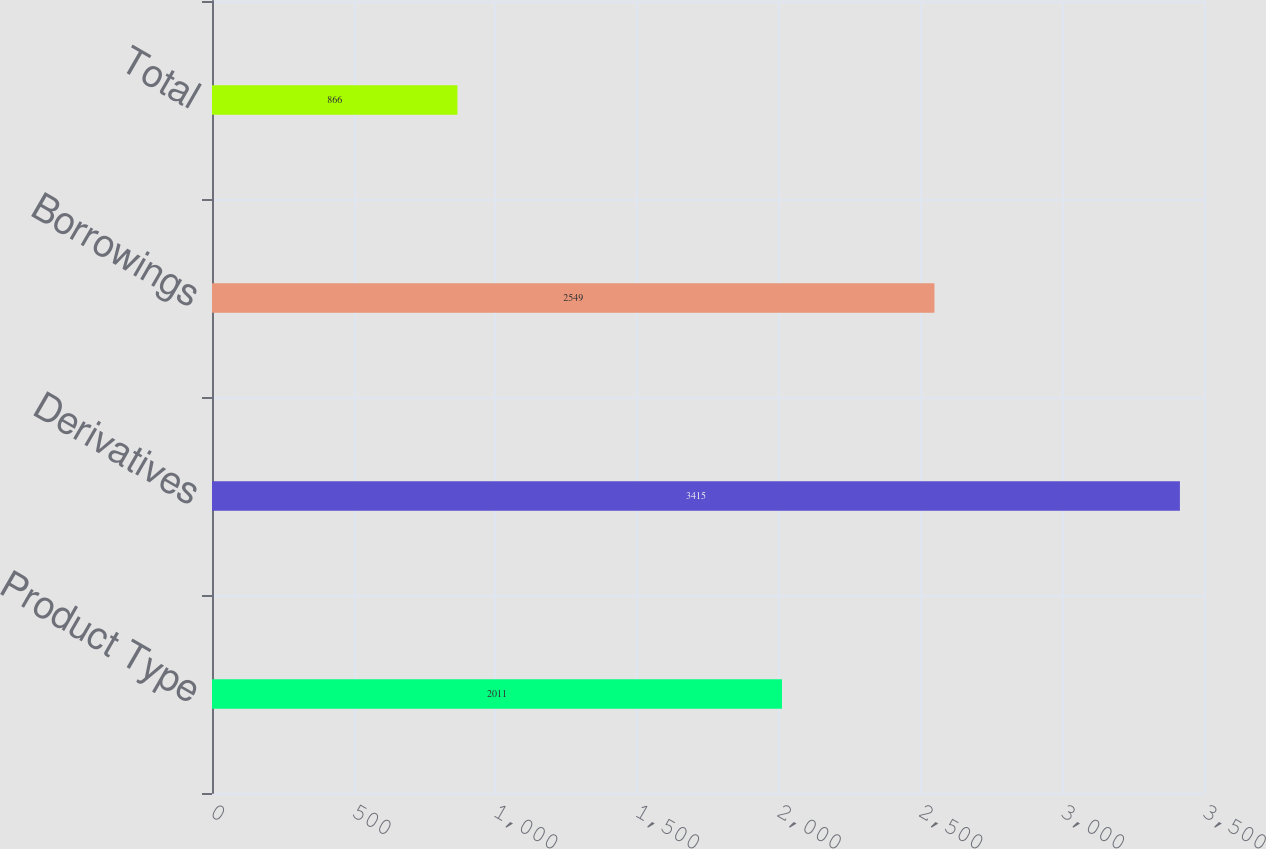Convert chart. <chart><loc_0><loc_0><loc_500><loc_500><bar_chart><fcel>Product Type<fcel>Derivatives<fcel>Borrowings<fcel>Total<nl><fcel>2011<fcel>3415<fcel>2549<fcel>866<nl></chart> 